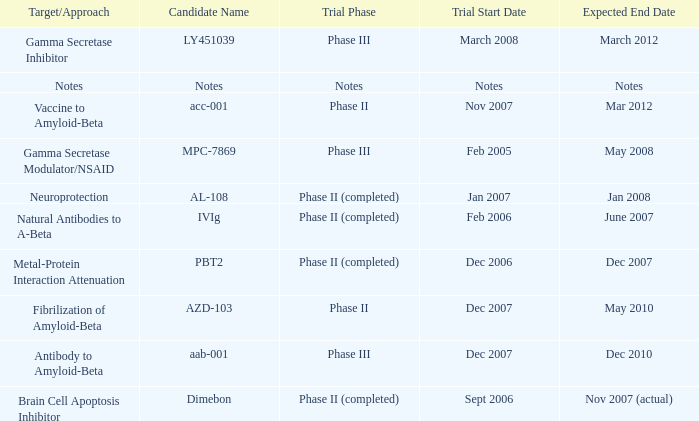What is Trial Phase, when Expected End Date is June 2007? Phase II (completed). 